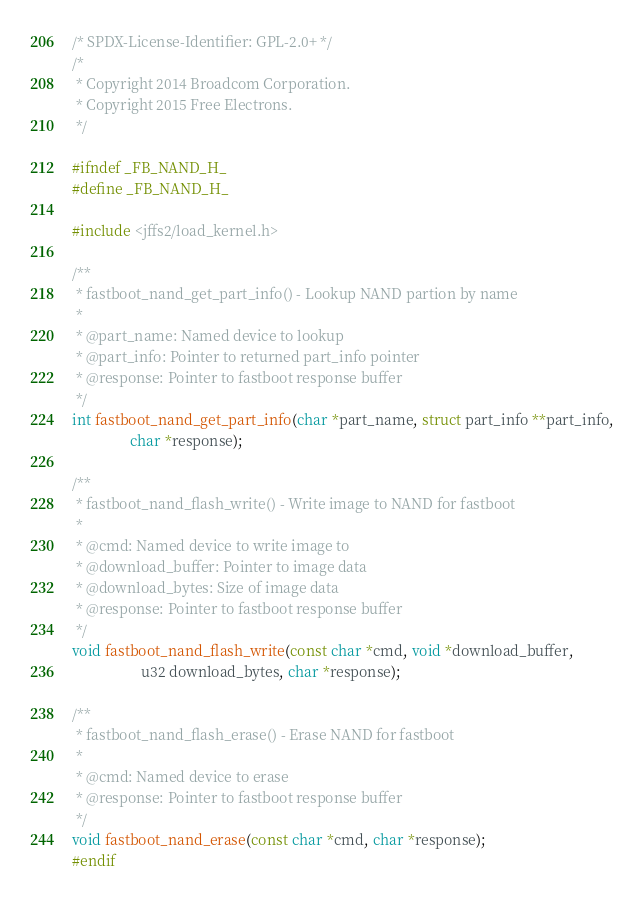Convert code to text. <code><loc_0><loc_0><loc_500><loc_500><_C_>/* SPDX-License-Identifier: GPL-2.0+ */
/*
 * Copyright 2014 Broadcom Corporation.
 * Copyright 2015 Free Electrons.
 */

#ifndef _FB_NAND_H_
#define _FB_NAND_H_

#include <jffs2/load_kernel.h>

/**
 * fastboot_nand_get_part_info() - Lookup NAND partion by name
 *
 * @part_name: Named device to lookup
 * @part_info: Pointer to returned part_info pointer
 * @response: Pointer to fastboot response buffer
 */
int fastboot_nand_get_part_info(char *part_name, struct part_info **part_info,
				char *response);

/**
 * fastboot_nand_flash_write() - Write image to NAND for fastboot
 *
 * @cmd: Named device to write image to
 * @download_buffer: Pointer to image data
 * @download_bytes: Size of image data
 * @response: Pointer to fastboot response buffer
 */
void fastboot_nand_flash_write(const char *cmd, void *download_buffer,
			       u32 download_bytes, char *response);

/**
 * fastboot_nand_flash_erase() - Erase NAND for fastboot
 *
 * @cmd: Named device to erase
 * @response: Pointer to fastboot response buffer
 */
void fastboot_nand_erase(const char *cmd, char *response);
#endif
</code> 